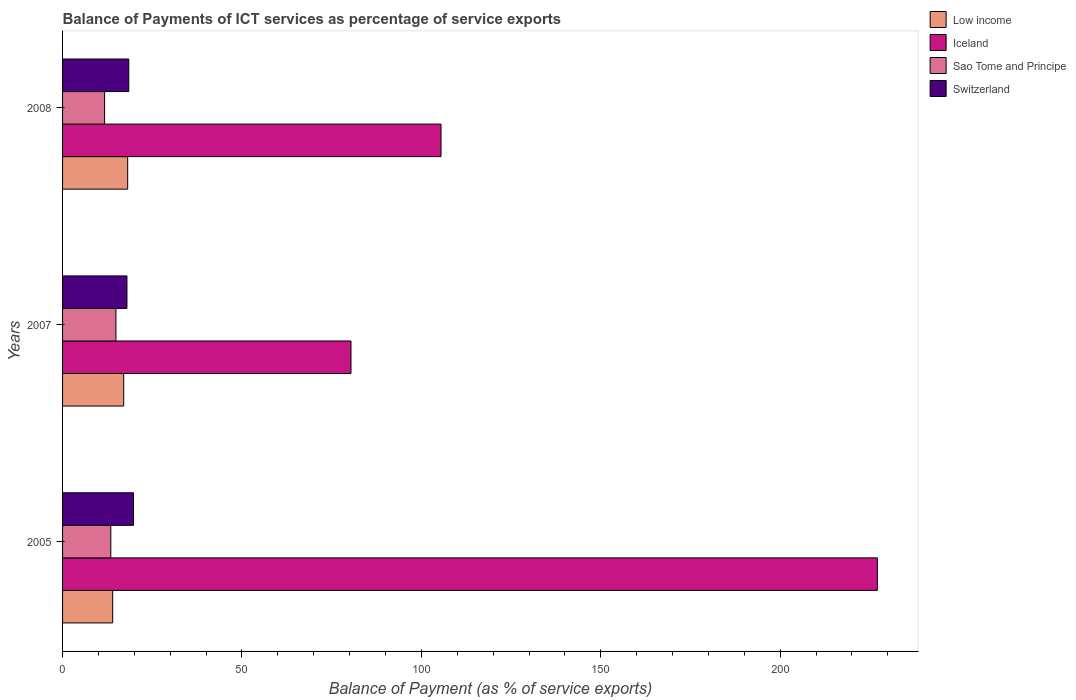How many different coloured bars are there?
Give a very brief answer. 4. Are the number of bars per tick equal to the number of legend labels?
Provide a succinct answer. Yes. What is the label of the 2nd group of bars from the top?
Ensure brevity in your answer.  2007. What is the balance of payments of ICT services in Sao Tome and Principe in 2005?
Your answer should be compact. 13.45. Across all years, what is the maximum balance of payments of ICT services in Switzerland?
Make the answer very short. 19.77. Across all years, what is the minimum balance of payments of ICT services in Sao Tome and Principe?
Your response must be concise. 11.72. In which year was the balance of payments of ICT services in Low income maximum?
Offer a very short reply. 2008. In which year was the balance of payments of ICT services in Switzerland minimum?
Make the answer very short. 2007. What is the total balance of payments of ICT services in Iceland in the graph?
Ensure brevity in your answer.  412.95. What is the difference between the balance of payments of ICT services in Iceland in 2005 and that in 2008?
Offer a terse response. 121.62. What is the difference between the balance of payments of ICT services in Sao Tome and Principe in 2005 and the balance of payments of ICT services in Low income in 2007?
Offer a terse response. -3.59. What is the average balance of payments of ICT services in Switzerland per year?
Make the answer very short. 18.72. In the year 2007, what is the difference between the balance of payments of ICT services in Low income and balance of payments of ICT services in Iceland?
Offer a terse response. -63.35. What is the ratio of the balance of payments of ICT services in Sao Tome and Principe in 2007 to that in 2008?
Your answer should be compact. 1.27. Is the balance of payments of ICT services in Sao Tome and Principe in 2007 less than that in 2008?
Ensure brevity in your answer.  No. Is the difference between the balance of payments of ICT services in Low income in 2005 and 2007 greater than the difference between the balance of payments of ICT services in Iceland in 2005 and 2007?
Provide a short and direct response. No. What is the difference between the highest and the second highest balance of payments of ICT services in Sao Tome and Principe?
Give a very brief answer. 1.43. What is the difference between the highest and the lowest balance of payments of ICT services in Switzerland?
Your answer should be very brief. 1.82. Is it the case that in every year, the sum of the balance of payments of ICT services in Sao Tome and Principe and balance of payments of ICT services in Low income is greater than the sum of balance of payments of ICT services in Iceland and balance of payments of ICT services in Switzerland?
Ensure brevity in your answer.  No. What does the 3rd bar from the top in 2005 represents?
Give a very brief answer. Iceland. Is it the case that in every year, the sum of the balance of payments of ICT services in Switzerland and balance of payments of ICT services in Low income is greater than the balance of payments of ICT services in Iceland?
Keep it short and to the point. No. Are all the bars in the graph horizontal?
Your answer should be compact. Yes. How many years are there in the graph?
Provide a succinct answer. 3. What is the difference between two consecutive major ticks on the X-axis?
Your answer should be very brief. 50. Are the values on the major ticks of X-axis written in scientific E-notation?
Keep it short and to the point. No. How many legend labels are there?
Your response must be concise. 4. How are the legend labels stacked?
Offer a very short reply. Vertical. What is the title of the graph?
Offer a terse response. Balance of Payments of ICT services as percentage of service exports. What is the label or title of the X-axis?
Your response must be concise. Balance of Payment (as % of service exports). What is the Balance of Payment (as % of service exports) in Low income in 2005?
Your answer should be very brief. 13.96. What is the Balance of Payment (as % of service exports) in Iceland in 2005?
Make the answer very short. 227.09. What is the Balance of Payment (as % of service exports) in Sao Tome and Principe in 2005?
Your answer should be very brief. 13.45. What is the Balance of Payment (as % of service exports) of Switzerland in 2005?
Make the answer very short. 19.77. What is the Balance of Payment (as % of service exports) of Low income in 2007?
Keep it short and to the point. 17.04. What is the Balance of Payment (as % of service exports) in Iceland in 2007?
Your answer should be compact. 80.38. What is the Balance of Payment (as % of service exports) in Sao Tome and Principe in 2007?
Give a very brief answer. 14.87. What is the Balance of Payment (as % of service exports) in Switzerland in 2007?
Provide a short and direct response. 17.94. What is the Balance of Payment (as % of service exports) of Low income in 2008?
Offer a very short reply. 18.15. What is the Balance of Payment (as % of service exports) of Iceland in 2008?
Give a very brief answer. 105.47. What is the Balance of Payment (as % of service exports) in Sao Tome and Principe in 2008?
Keep it short and to the point. 11.72. What is the Balance of Payment (as % of service exports) in Switzerland in 2008?
Provide a short and direct response. 18.46. Across all years, what is the maximum Balance of Payment (as % of service exports) in Low income?
Make the answer very short. 18.15. Across all years, what is the maximum Balance of Payment (as % of service exports) of Iceland?
Offer a very short reply. 227.09. Across all years, what is the maximum Balance of Payment (as % of service exports) in Sao Tome and Principe?
Offer a terse response. 14.87. Across all years, what is the maximum Balance of Payment (as % of service exports) in Switzerland?
Your answer should be very brief. 19.77. Across all years, what is the minimum Balance of Payment (as % of service exports) of Low income?
Offer a terse response. 13.96. Across all years, what is the minimum Balance of Payment (as % of service exports) of Iceland?
Give a very brief answer. 80.38. Across all years, what is the minimum Balance of Payment (as % of service exports) of Sao Tome and Principe?
Your answer should be compact. 11.72. Across all years, what is the minimum Balance of Payment (as % of service exports) of Switzerland?
Ensure brevity in your answer.  17.94. What is the total Balance of Payment (as % of service exports) of Low income in the graph?
Keep it short and to the point. 49.15. What is the total Balance of Payment (as % of service exports) of Iceland in the graph?
Ensure brevity in your answer.  412.95. What is the total Balance of Payment (as % of service exports) in Sao Tome and Principe in the graph?
Give a very brief answer. 40.04. What is the total Balance of Payment (as % of service exports) in Switzerland in the graph?
Keep it short and to the point. 56.17. What is the difference between the Balance of Payment (as % of service exports) of Low income in 2005 and that in 2007?
Offer a terse response. -3.08. What is the difference between the Balance of Payment (as % of service exports) in Iceland in 2005 and that in 2007?
Your response must be concise. 146.71. What is the difference between the Balance of Payment (as % of service exports) in Sao Tome and Principe in 2005 and that in 2007?
Provide a short and direct response. -1.43. What is the difference between the Balance of Payment (as % of service exports) in Switzerland in 2005 and that in 2007?
Offer a very short reply. 1.82. What is the difference between the Balance of Payment (as % of service exports) of Low income in 2005 and that in 2008?
Give a very brief answer. -4.19. What is the difference between the Balance of Payment (as % of service exports) in Iceland in 2005 and that in 2008?
Your answer should be very brief. 121.62. What is the difference between the Balance of Payment (as % of service exports) of Sao Tome and Principe in 2005 and that in 2008?
Offer a terse response. 1.72. What is the difference between the Balance of Payment (as % of service exports) in Switzerland in 2005 and that in 2008?
Your response must be concise. 1.31. What is the difference between the Balance of Payment (as % of service exports) of Low income in 2007 and that in 2008?
Keep it short and to the point. -1.11. What is the difference between the Balance of Payment (as % of service exports) of Iceland in 2007 and that in 2008?
Give a very brief answer. -25.09. What is the difference between the Balance of Payment (as % of service exports) in Sao Tome and Principe in 2007 and that in 2008?
Provide a short and direct response. 3.15. What is the difference between the Balance of Payment (as % of service exports) of Switzerland in 2007 and that in 2008?
Offer a very short reply. -0.51. What is the difference between the Balance of Payment (as % of service exports) in Low income in 2005 and the Balance of Payment (as % of service exports) in Iceland in 2007?
Your answer should be compact. -66.42. What is the difference between the Balance of Payment (as % of service exports) in Low income in 2005 and the Balance of Payment (as % of service exports) in Sao Tome and Principe in 2007?
Ensure brevity in your answer.  -0.91. What is the difference between the Balance of Payment (as % of service exports) of Low income in 2005 and the Balance of Payment (as % of service exports) of Switzerland in 2007?
Ensure brevity in your answer.  -3.98. What is the difference between the Balance of Payment (as % of service exports) of Iceland in 2005 and the Balance of Payment (as % of service exports) of Sao Tome and Principe in 2007?
Make the answer very short. 212.22. What is the difference between the Balance of Payment (as % of service exports) of Iceland in 2005 and the Balance of Payment (as % of service exports) of Switzerland in 2007?
Your answer should be compact. 209.15. What is the difference between the Balance of Payment (as % of service exports) in Sao Tome and Principe in 2005 and the Balance of Payment (as % of service exports) in Switzerland in 2007?
Offer a very short reply. -4.5. What is the difference between the Balance of Payment (as % of service exports) of Low income in 2005 and the Balance of Payment (as % of service exports) of Iceland in 2008?
Provide a short and direct response. -91.51. What is the difference between the Balance of Payment (as % of service exports) of Low income in 2005 and the Balance of Payment (as % of service exports) of Sao Tome and Principe in 2008?
Provide a short and direct response. 2.24. What is the difference between the Balance of Payment (as % of service exports) in Low income in 2005 and the Balance of Payment (as % of service exports) in Switzerland in 2008?
Give a very brief answer. -4.49. What is the difference between the Balance of Payment (as % of service exports) of Iceland in 2005 and the Balance of Payment (as % of service exports) of Sao Tome and Principe in 2008?
Your response must be concise. 215.37. What is the difference between the Balance of Payment (as % of service exports) of Iceland in 2005 and the Balance of Payment (as % of service exports) of Switzerland in 2008?
Your answer should be compact. 208.64. What is the difference between the Balance of Payment (as % of service exports) in Sao Tome and Principe in 2005 and the Balance of Payment (as % of service exports) in Switzerland in 2008?
Your answer should be very brief. -5.01. What is the difference between the Balance of Payment (as % of service exports) of Low income in 2007 and the Balance of Payment (as % of service exports) of Iceland in 2008?
Provide a succinct answer. -88.44. What is the difference between the Balance of Payment (as % of service exports) of Low income in 2007 and the Balance of Payment (as % of service exports) of Sao Tome and Principe in 2008?
Your response must be concise. 5.31. What is the difference between the Balance of Payment (as % of service exports) in Low income in 2007 and the Balance of Payment (as % of service exports) in Switzerland in 2008?
Your answer should be very brief. -1.42. What is the difference between the Balance of Payment (as % of service exports) in Iceland in 2007 and the Balance of Payment (as % of service exports) in Sao Tome and Principe in 2008?
Your response must be concise. 68.66. What is the difference between the Balance of Payment (as % of service exports) of Iceland in 2007 and the Balance of Payment (as % of service exports) of Switzerland in 2008?
Give a very brief answer. 61.93. What is the difference between the Balance of Payment (as % of service exports) in Sao Tome and Principe in 2007 and the Balance of Payment (as % of service exports) in Switzerland in 2008?
Your answer should be compact. -3.58. What is the average Balance of Payment (as % of service exports) of Low income per year?
Offer a very short reply. 16.38. What is the average Balance of Payment (as % of service exports) of Iceland per year?
Offer a very short reply. 137.65. What is the average Balance of Payment (as % of service exports) of Sao Tome and Principe per year?
Your response must be concise. 13.35. What is the average Balance of Payment (as % of service exports) in Switzerland per year?
Your answer should be very brief. 18.72. In the year 2005, what is the difference between the Balance of Payment (as % of service exports) in Low income and Balance of Payment (as % of service exports) in Iceland?
Offer a very short reply. -213.13. In the year 2005, what is the difference between the Balance of Payment (as % of service exports) of Low income and Balance of Payment (as % of service exports) of Sao Tome and Principe?
Make the answer very short. 0.51. In the year 2005, what is the difference between the Balance of Payment (as % of service exports) of Low income and Balance of Payment (as % of service exports) of Switzerland?
Make the answer very short. -5.8. In the year 2005, what is the difference between the Balance of Payment (as % of service exports) of Iceland and Balance of Payment (as % of service exports) of Sao Tome and Principe?
Your response must be concise. 213.64. In the year 2005, what is the difference between the Balance of Payment (as % of service exports) of Iceland and Balance of Payment (as % of service exports) of Switzerland?
Provide a short and direct response. 207.33. In the year 2005, what is the difference between the Balance of Payment (as % of service exports) in Sao Tome and Principe and Balance of Payment (as % of service exports) in Switzerland?
Make the answer very short. -6.32. In the year 2007, what is the difference between the Balance of Payment (as % of service exports) of Low income and Balance of Payment (as % of service exports) of Iceland?
Ensure brevity in your answer.  -63.35. In the year 2007, what is the difference between the Balance of Payment (as % of service exports) of Low income and Balance of Payment (as % of service exports) of Sao Tome and Principe?
Make the answer very short. 2.16. In the year 2007, what is the difference between the Balance of Payment (as % of service exports) in Low income and Balance of Payment (as % of service exports) in Switzerland?
Your answer should be very brief. -0.91. In the year 2007, what is the difference between the Balance of Payment (as % of service exports) in Iceland and Balance of Payment (as % of service exports) in Sao Tome and Principe?
Your answer should be very brief. 65.51. In the year 2007, what is the difference between the Balance of Payment (as % of service exports) in Iceland and Balance of Payment (as % of service exports) in Switzerland?
Provide a short and direct response. 62.44. In the year 2007, what is the difference between the Balance of Payment (as % of service exports) in Sao Tome and Principe and Balance of Payment (as % of service exports) in Switzerland?
Provide a succinct answer. -3.07. In the year 2008, what is the difference between the Balance of Payment (as % of service exports) of Low income and Balance of Payment (as % of service exports) of Iceland?
Ensure brevity in your answer.  -87.32. In the year 2008, what is the difference between the Balance of Payment (as % of service exports) of Low income and Balance of Payment (as % of service exports) of Sao Tome and Principe?
Your answer should be compact. 6.43. In the year 2008, what is the difference between the Balance of Payment (as % of service exports) in Low income and Balance of Payment (as % of service exports) in Switzerland?
Give a very brief answer. -0.31. In the year 2008, what is the difference between the Balance of Payment (as % of service exports) in Iceland and Balance of Payment (as % of service exports) in Sao Tome and Principe?
Make the answer very short. 93.75. In the year 2008, what is the difference between the Balance of Payment (as % of service exports) in Iceland and Balance of Payment (as % of service exports) in Switzerland?
Offer a very short reply. 87.02. In the year 2008, what is the difference between the Balance of Payment (as % of service exports) in Sao Tome and Principe and Balance of Payment (as % of service exports) in Switzerland?
Provide a succinct answer. -6.73. What is the ratio of the Balance of Payment (as % of service exports) in Low income in 2005 to that in 2007?
Make the answer very short. 0.82. What is the ratio of the Balance of Payment (as % of service exports) of Iceland in 2005 to that in 2007?
Provide a succinct answer. 2.83. What is the ratio of the Balance of Payment (as % of service exports) of Sao Tome and Principe in 2005 to that in 2007?
Provide a succinct answer. 0.9. What is the ratio of the Balance of Payment (as % of service exports) in Switzerland in 2005 to that in 2007?
Your answer should be compact. 1.1. What is the ratio of the Balance of Payment (as % of service exports) in Low income in 2005 to that in 2008?
Offer a terse response. 0.77. What is the ratio of the Balance of Payment (as % of service exports) in Iceland in 2005 to that in 2008?
Keep it short and to the point. 2.15. What is the ratio of the Balance of Payment (as % of service exports) of Sao Tome and Principe in 2005 to that in 2008?
Your answer should be very brief. 1.15. What is the ratio of the Balance of Payment (as % of service exports) of Switzerland in 2005 to that in 2008?
Your answer should be very brief. 1.07. What is the ratio of the Balance of Payment (as % of service exports) in Low income in 2007 to that in 2008?
Your answer should be compact. 0.94. What is the ratio of the Balance of Payment (as % of service exports) of Iceland in 2007 to that in 2008?
Your response must be concise. 0.76. What is the ratio of the Balance of Payment (as % of service exports) in Sao Tome and Principe in 2007 to that in 2008?
Your answer should be very brief. 1.27. What is the ratio of the Balance of Payment (as % of service exports) in Switzerland in 2007 to that in 2008?
Offer a terse response. 0.97. What is the difference between the highest and the second highest Balance of Payment (as % of service exports) of Low income?
Your response must be concise. 1.11. What is the difference between the highest and the second highest Balance of Payment (as % of service exports) in Iceland?
Give a very brief answer. 121.62. What is the difference between the highest and the second highest Balance of Payment (as % of service exports) in Sao Tome and Principe?
Make the answer very short. 1.43. What is the difference between the highest and the second highest Balance of Payment (as % of service exports) in Switzerland?
Your answer should be compact. 1.31. What is the difference between the highest and the lowest Balance of Payment (as % of service exports) of Low income?
Offer a very short reply. 4.19. What is the difference between the highest and the lowest Balance of Payment (as % of service exports) in Iceland?
Give a very brief answer. 146.71. What is the difference between the highest and the lowest Balance of Payment (as % of service exports) of Sao Tome and Principe?
Provide a short and direct response. 3.15. What is the difference between the highest and the lowest Balance of Payment (as % of service exports) in Switzerland?
Offer a very short reply. 1.82. 